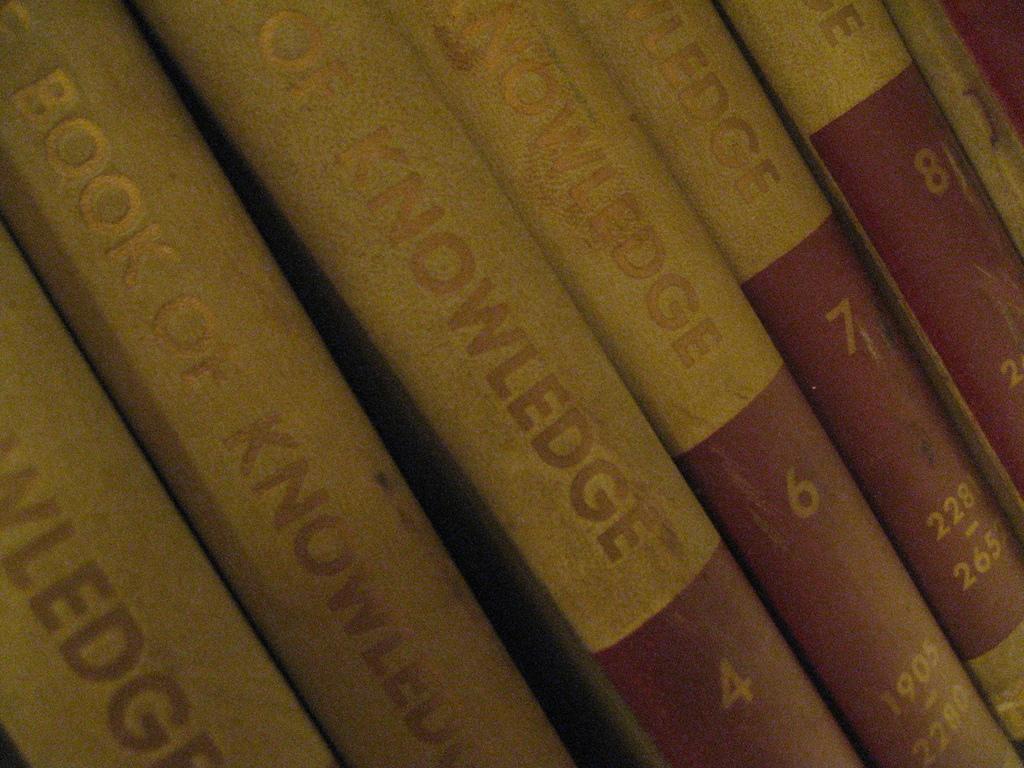What are the titles of these books or encyclopedias?
Provide a succinct answer. Book of knowledge. What's the title of the book series?
Provide a succinct answer. Book of knowledge. 